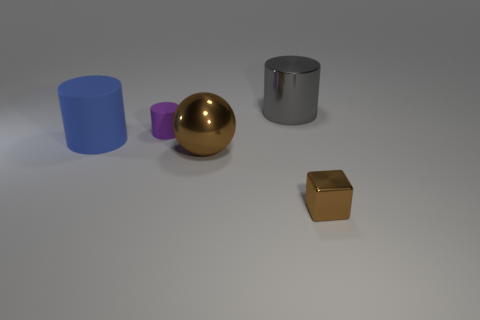Is there any other thing that has the same shape as the big brown shiny object?
Give a very brief answer. No. Are there any tiny brown things that are in front of the big cylinder to the right of the big rubber thing?
Make the answer very short. Yes. Do the small thing that is to the left of the big gray shiny cylinder and the blue rubber thing that is behind the brown metallic sphere have the same shape?
Offer a very short reply. Yes. Do the brown object to the left of the small brown block and the big cylinder on the left side of the small purple object have the same material?
Your answer should be compact. No. There is a small thing that is left of the big metallic thing behind the purple matte cylinder; what is its material?
Offer a terse response. Rubber. What is the shape of the big blue thing to the left of the metal object that is to the right of the big shiny thing behind the big blue cylinder?
Give a very brief answer. Cylinder. There is a purple object that is the same shape as the big blue matte object; what is its material?
Your answer should be compact. Rubber. What number of blocks are there?
Offer a very short reply. 1. What is the shape of the rubber object behind the large rubber cylinder?
Keep it short and to the point. Cylinder. What color is the big shiny thing that is behind the small object behind the big metallic object that is in front of the purple rubber object?
Make the answer very short. Gray. 